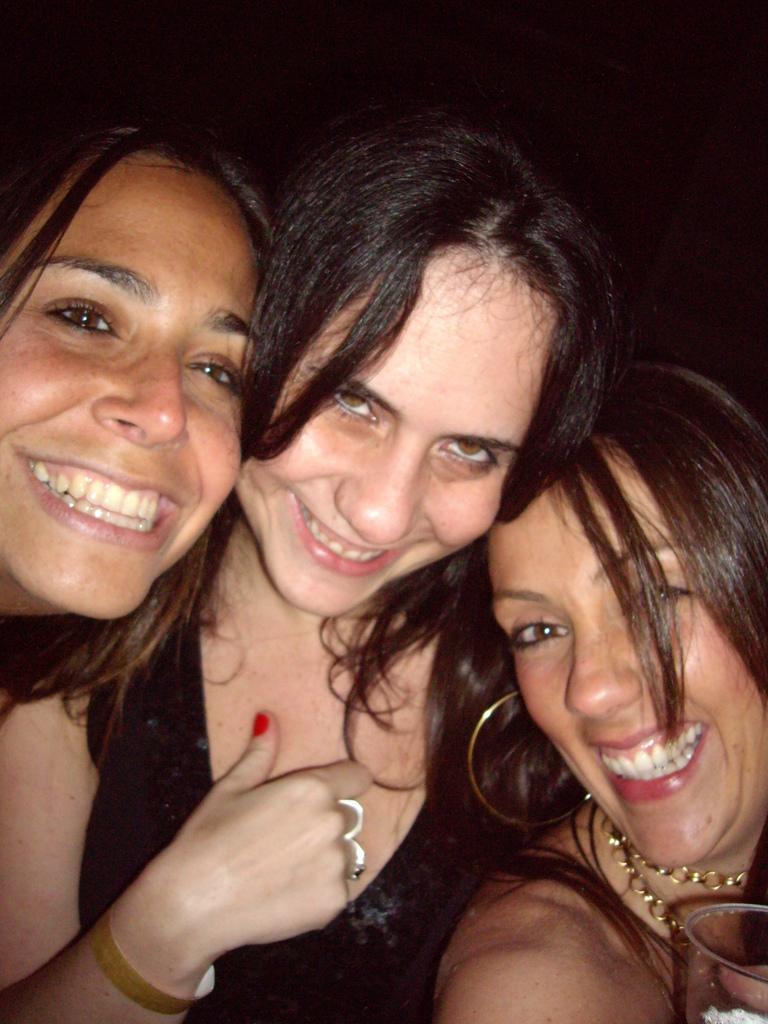How would you summarize this image in a sentence or two? In this image we can see three women. One woman is wearing black dress and one woman is holding a glass in her hand. 